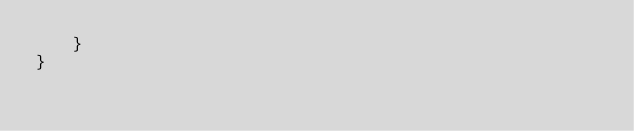Convert code to text. <code><loc_0><loc_0><loc_500><loc_500><_ObjectiveC_>    }
}
</code> 